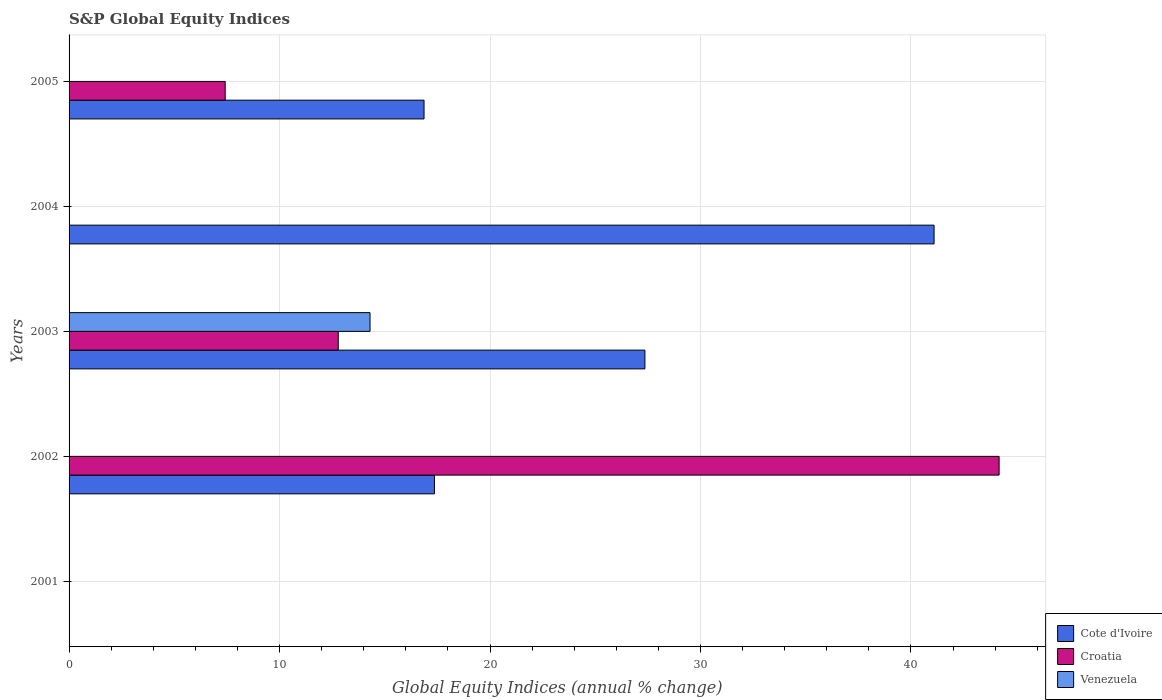How many different coloured bars are there?
Provide a succinct answer. 3. How many bars are there on the 2nd tick from the bottom?
Your answer should be compact. 2. What is the label of the 5th group of bars from the top?
Your answer should be compact. 2001. In how many cases, is the number of bars for a given year not equal to the number of legend labels?
Your answer should be compact. 4. What is the global equity indices in Venezuela in 2002?
Offer a very short reply. 0. Across all years, what is the maximum global equity indices in Cote d'Ivoire?
Provide a succinct answer. 41.1. What is the total global equity indices in Cote d'Ivoire in the graph?
Offer a terse response. 102.69. What is the difference between the global equity indices in Cote d'Ivoire in 2003 and that in 2005?
Your answer should be compact. 10.49. What is the difference between the global equity indices in Croatia in 2005 and the global equity indices in Cote d'Ivoire in 2003?
Your answer should be very brief. -19.94. What is the average global equity indices in Venezuela per year?
Ensure brevity in your answer.  2.86. In the year 2003, what is the difference between the global equity indices in Cote d'Ivoire and global equity indices in Croatia?
Provide a short and direct response. 14.57. What is the ratio of the global equity indices in Cote d'Ivoire in 2003 to that in 2005?
Give a very brief answer. 1.62. Is the global equity indices in Croatia in 2002 less than that in 2005?
Your response must be concise. No. What is the difference between the highest and the second highest global equity indices in Croatia?
Your answer should be very brief. 31.4. What is the difference between the highest and the lowest global equity indices in Cote d'Ivoire?
Make the answer very short. 41.1. Is the sum of the global equity indices in Croatia in 2002 and 2005 greater than the maximum global equity indices in Cote d'Ivoire across all years?
Make the answer very short. Yes. How many bars are there?
Offer a very short reply. 8. Are all the bars in the graph horizontal?
Provide a short and direct response. Yes. What is the difference between two consecutive major ticks on the X-axis?
Ensure brevity in your answer.  10. Are the values on the major ticks of X-axis written in scientific E-notation?
Ensure brevity in your answer.  No. Does the graph contain any zero values?
Provide a succinct answer. Yes. How many legend labels are there?
Your answer should be very brief. 3. How are the legend labels stacked?
Offer a terse response. Vertical. What is the title of the graph?
Your response must be concise. S&P Global Equity Indices. What is the label or title of the X-axis?
Your answer should be very brief. Global Equity Indices (annual % change). What is the label or title of the Y-axis?
Your answer should be very brief. Years. What is the Global Equity Indices (annual % change) of Croatia in 2001?
Your response must be concise. 0. What is the Global Equity Indices (annual % change) of Venezuela in 2001?
Your answer should be very brief. 0. What is the Global Equity Indices (annual % change) of Cote d'Ivoire in 2002?
Your response must be concise. 17.36. What is the Global Equity Indices (annual % change) in Croatia in 2002?
Your answer should be very brief. 44.19. What is the Global Equity Indices (annual % change) in Cote d'Ivoire in 2003?
Give a very brief answer. 27.36. What is the Global Equity Indices (annual % change) in Croatia in 2003?
Provide a succinct answer. 12.79. What is the Global Equity Indices (annual % change) in Venezuela in 2003?
Offer a very short reply. 14.3. What is the Global Equity Indices (annual % change) of Cote d'Ivoire in 2004?
Offer a very short reply. 41.1. What is the Global Equity Indices (annual % change) of Croatia in 2004?
Your response must be concise. 0. What is the Global Equity Indices (annual % change) in Cote d'Ivoire in 2005?
Offer a very short reply. 16.87. What is the Global Equity Indices (annual % change) in Croatia in 2005?
Keep it short and to the point. 7.42. What is the Global Equity Indices (annual % change) in Venezuela in 2005?
Ensure brevity in your answer.  0. Across all years, what is the maximum Global Equity Indices (annual % change) of Cote d'Ivoire?
Your answer should be very brief. 41.1. Across all years, what is the maximum Global Equity Indices (annual % change) of Croatia?
Provide a succinct answer. 44.19. Across all years, what is the maximum Global Equity Indices (annual % change) in Venezuela?
Your answer should be compact. 14.3. Across all years, what is the minimum Global Equity Indices (annual % change) of Croatia?
Provide a short and direct response. 0. What is the total Global Equity Indices (annual % change) in Cote d'Ivoire in the graph?
Your response must be concise. 102.69. What is the total Global Equity Indices (annual % change) in Croatia in the graph?
Your response must be concise. 64.4. What is the total Global Equity Indices (annual % change) of Venezuela in the graph?
Give a very brief answer. 14.3. What is the difference between the Global Equity Indices (annual % change) in Croatia in 2002 and that in 2003?
Offer a very short reply. 31.4. What is the difference between the Global Equity Indices (annual % change) in Cote d'Ivoire in 2002 and that in 2004?
Give a very brief answer. -23.74. What is the difference between the Global Equity Indices (annual % change) of Cote d'Ivoire in 2002 and that in 2005?
Your answer should be compact. 0.49. What is the difference between the Global Equity Indices (annual % change) of Croatia in 2002 and that in 2005?
Your answer should be very brief. 36.77. What is the difference between the Global Equity Indices (annual % change) of Cote d'Ivoire in 2003 and that in 2004?
Your answer should be compact. -13.74. What is the difference between the Global Equity Indices (annual % change) of Cote d'Ivoire in 2003 and that in 2005?
Give a very brief answer. 10.49. What is the difference between the Global Equity Indices (annual % change) in Croatia in 2003 and that in 2005?
Your answer should be very brief. 5.37. What is the difference between the Global Equity Indices (annual % change) of Cote d'Ivoire in 2004 and that in 2005?
Offer a very short reply. 24.23. What is the difference between the Global Equity Indices (annual % change) in Cote d'Ivoire in 2002 and the Global Equity Indices (annual % change) in Croatia in 2003?
Make the answer very short. 4.57. What is the difference between the Global Equity Indices (annual % change) in Cote d'Ivoire in 2002 and the Global Equity Indices (annual % change) in Venezuela in 2003?
Offer a very short reply. 3.06. What is the difference between the Global Equity Indices (annual % change) in Croatia in 2002 and the Global Equity Indices (annual % change) in Venezuela in 2003?
Provide a short and direct response. 29.89. What is the difference between the Global Equity Indices (annual % change) of Cote d'Ivoire in 2002 and the Global Equity Indices (annual % change) of Croatia in 2005?
Ensure brevity in your answer.  9.94. What is the difference between the Global Equity Indices (annual % change) of Cote d'Ivoire in 2003 and the Global Equity Indices (annual % change) of Croatia in 2005?
Your answer should be compact. 19.94. What is the difference between the Global Equity Indices (annual % change) of Cote d'Ivoire in 2004 and the Global Equity Indices (annual % change) of Croatia in 2005?
Your answer should be very brief. 33.68. What is the average Global Equity Indices (annual % change) in Cote d'Ivoire per year?
Keep it short and to the point. 20.54. What is the average Global Equity Indices (annual % change) of Croatia per year?
Your response must be concise. 12.88. What is the average Global Equity Indices (annual % change) in Venezuela per year?
Your answer should be compact. 2.86. In the year 2002, what is the difference between the Global Equity Indices (annual % change) of Cote d'Ivoire and Global Equity Indices (annual % change) of Croatia?
Make the answer very short. -26.83. In the year 2003, what is the difference between the Global Equity Indices (annual % change) in Cote d'Ivoire and Global Equity Indices (annual % change) in Croatia?
Provide a succinct answer. 14.57. In the year 2003, what is the difference between the Global Equity Indices (annual % change) of Cote d'Ivoire and Global Equity Indices (annual % change) of Venezuela?
Give a very brief answer. 13.06. In the year 2003, what is the difference between the Global Equity Indices (annual % change) of Croatia and Global Equity Indices (annual % change) of Venezuela?
Keep it short and to the point. -1.51. In the year 2005, what is the difference between the Global Equity Indices (annual % change) of Cote d'Ivoire and Global Equity Indices (annual % change) of Croatia?
Make the answer very short. 9.45. What is the ratio of the Global Equity Indices (annual % change) in Cote d'Ivoire in 2002 to that in 2003?
Offer a very short reply. 0.63. What is the ratio of the Global Equity Indices (annual % change) of Croatia in 2002 to that in 2003?
Provide a short and direct response. 3.46. What is the ratio of the Global Equity Indices (annual % change) in Cote d'Ivoire in 2002 to that in 2004?
Provide a succinct answer. 0.42. What is the ratio of the Global Equity Indices (annual % change) of Cote d'Ivoire in 2002 to that in 2005?
Provide a succinct answer. 1.03. What is the ratio of the Global Equity Indices (annual % change) of Croatia in 2002 to that in 2005?
Provide a short and direct response. 5.96. What is the ratio of the Global Equity Indices (annual % change) of Cote d'Ivoire in 2003 to that in 2004?
Provide a short and direct response. 0.67. What is the ratio of the Global Equity Indices (annual % change) in Cote d'Ivoire in 2003 to that in 2005?
Keep it short and to the point. 1.62. What is the ratio of the Global Equity Indices (annual % change) of Croatia in 2003 to that in 2005?
Keep it short and to the point. 1.72. What is the ratio of the Global Equity Indices (annual % change) in Cote d'Ivoire in 2004 to that in 2005?
Your response must be concise. 2.44. What is the difference between the highest and the second highest Global Equity Indices (annual % change) of Cote d'Ivoire?
Make the answer very short. 13.74. What is the difference between the highest and the second highest Global Equity Indices (annual % change) of Croatia?
Provide a succinct answer. 31.4. What is the difference between the highest and the lowest Global Equity Indices (annual % change) in Cote d'Ivoire?
Provide a short and direct response. 41.1. What is the difference between the highest and the lowest Global Equity Indices (annual % change) of Croatia?
Provide a succinct answer. 44.19. 